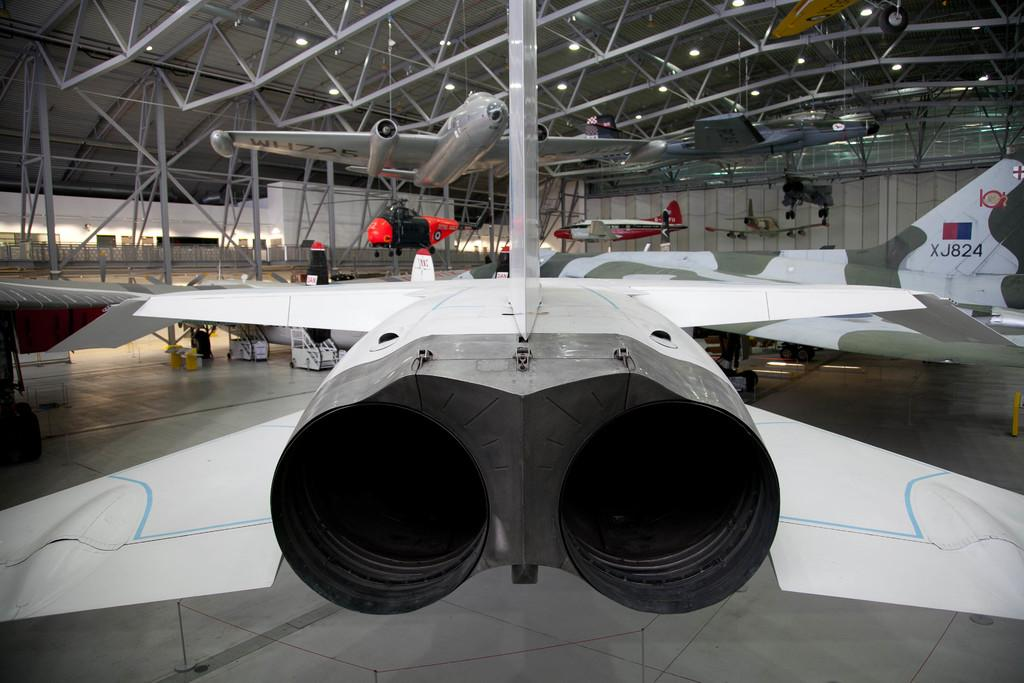What is the main subject of the image? The main subject of the image is aircrafts. What can be seen in the background of the image? There are poles in the background of the image. What type of lighting is present in the image? There are lights on the ceiling in the image. What type of jeans is the person wearing in the image? There is no person or jeans present in the image; it features aircrafts and poles in the background. 